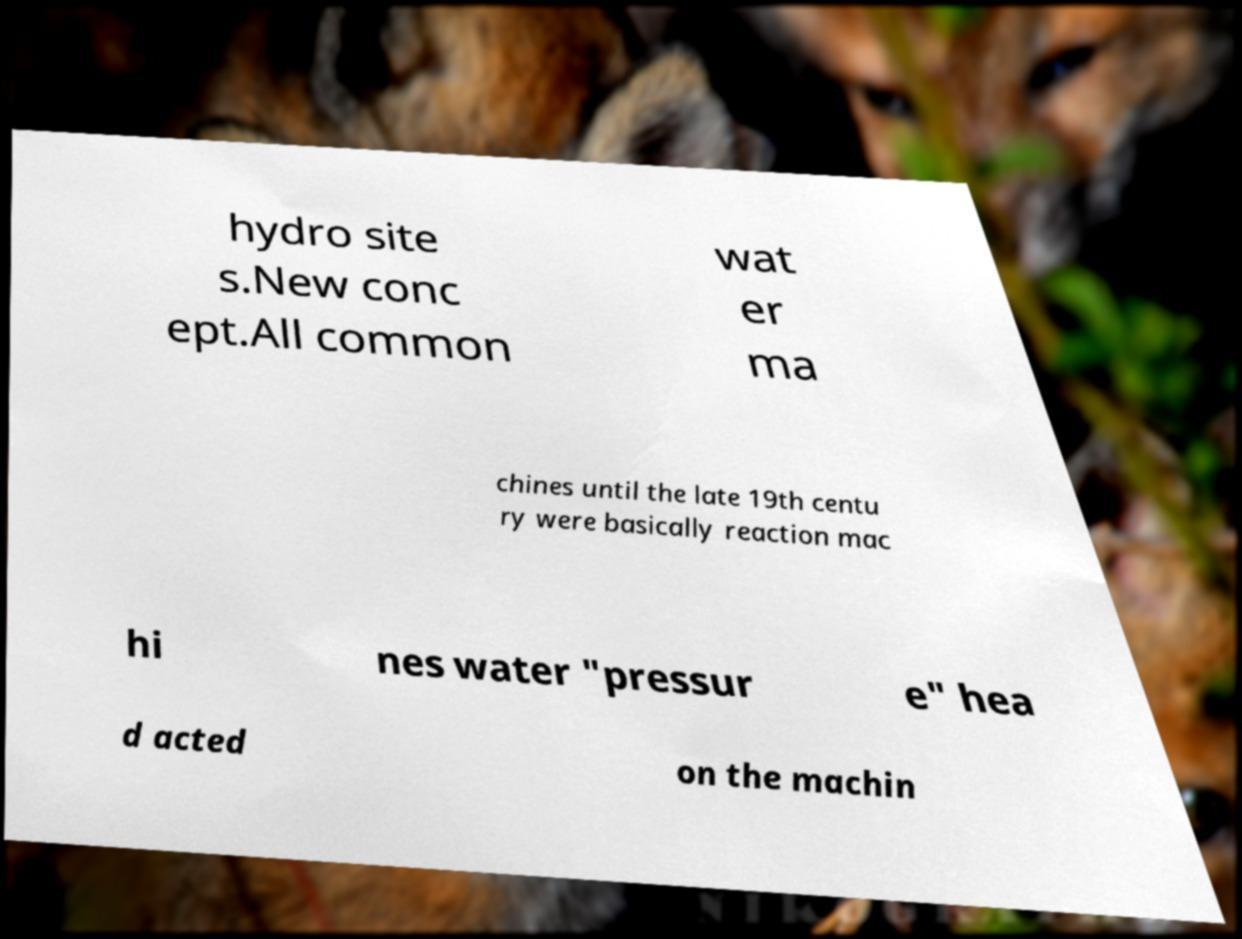There's text embedded in this image that I need extracted. Can you transcribe it verbatim? hydro site s.New conc ept.All common wat er ma chines until the late 19th centu ry were basically reaction mac hi nes water "pressur e" hea d acted on the machin 